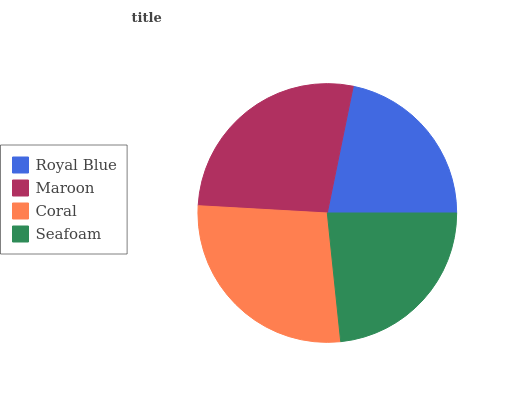Is Royal Blue the minimum?
Answer yes or no. Yes. Is Coral the maximum?
Answer yes or no. Yes. Is Maroon the minimum?
Answer yes or no. No. Is Maroon the maximum?
Answer yes or no. No. Is Maroon greater than Royal Blue?
Answer yes or no. Yes. Is Royal Blue less than Maroon?
Answer yes or no. Yes. Is Royal Blue greater than Maroon?
Answer yes or no. No. Is Maroon less than Royal Blue?
Answer yes or no. No. Is Maroon the high median?
Answer yes or no. Yes. Is Seafoam the low median?
Answer yes or no. Yes. Is Seafoam the high median?
Answer yes or no. No. Is Coral the low median?
Answer yes or no. No. 